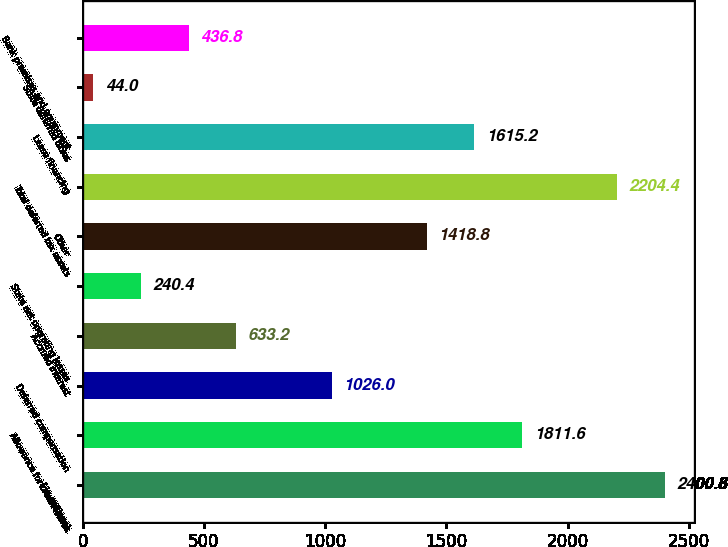Convert chart to OTSL. <chart><loc_0><loc_0><loc_500><loc_500><bar_chart><fcel>( in millions)<fcel>Allowance for credit losses<fcel>Deferred compensation<fcel>Accrued interest<fcel>State net operating losses<fcel>Other<fcel>Total deferred tax assets<fcel>Lease financing<fcel>State deferred taxes<fcel>Bank premises and equipment<nl><fcel>2400.8<fcel>1811.6<fcel>1026<fcel>633.2<fcel>240.4<fcel>1418.8<fcel>2204.4<fcel>1615.2<fcel>44<fcel>436.8<nl></chart> 